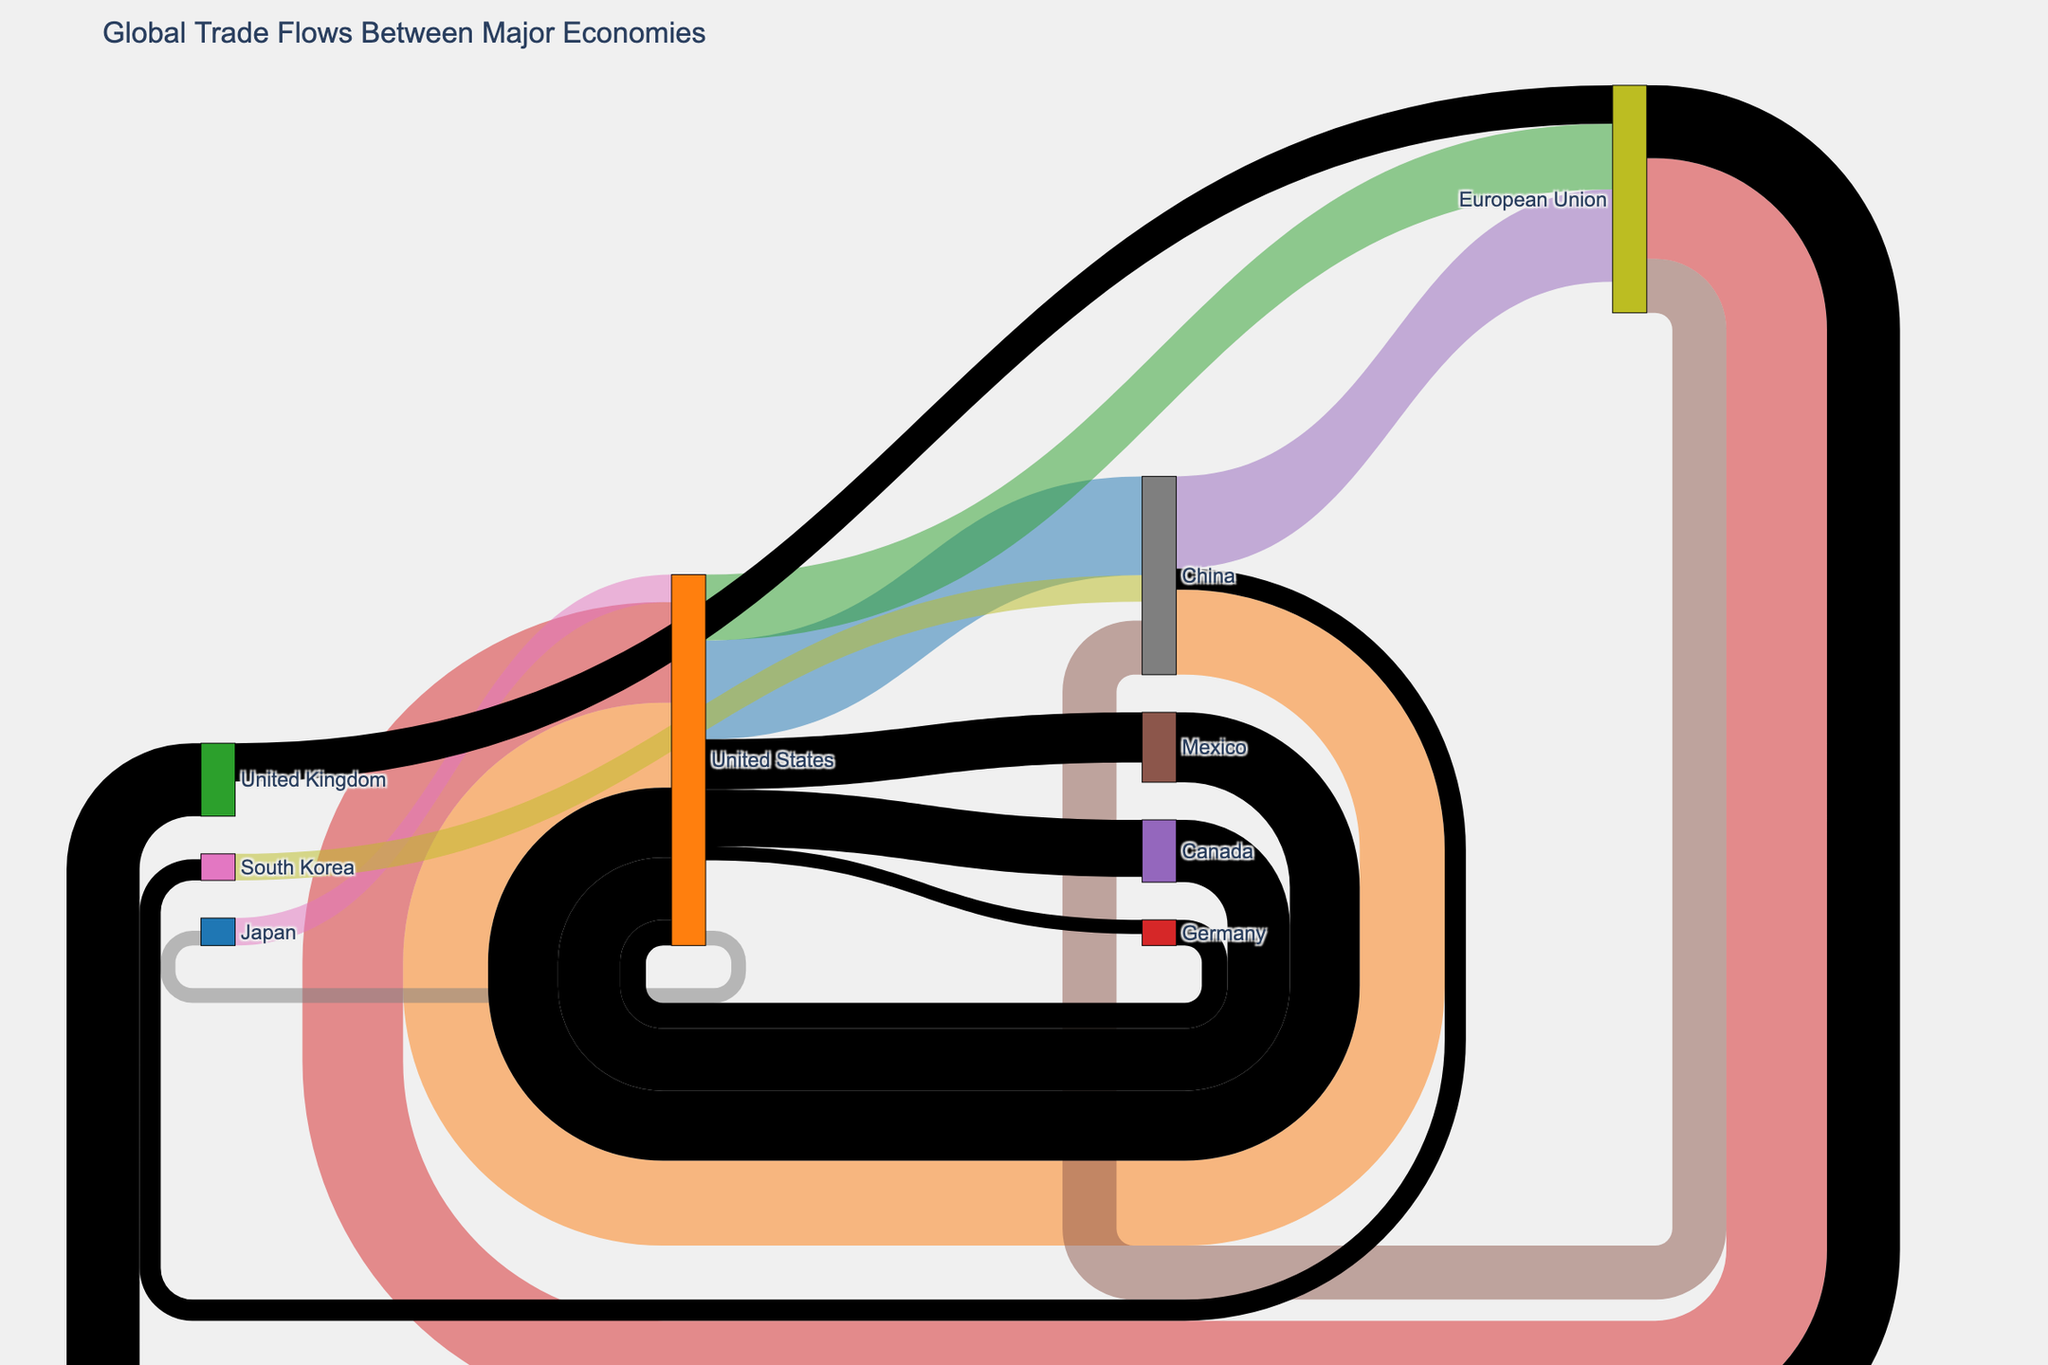What's the total value of exports from the United States to China and the European Union? Summing the export values from the United States to China (506.4) and the European Union (337.2) gives 506.4 + 337.2 = 843.6.
Answer: 843.6 Which country has the highest trade volume with the European Union? Comparing the trade flows between China, the United States, and the United Kingdom with the European Union, the United States has the highest value (515.6).
Answer: United States Does the United States import more from Germany or Japan? The import value from Germany is 131.6, while from Japan it is 140.7. Since 140.7 > 131.6, the United States imports more from Japan.
Answer: Japan What is the total volume of trade between the United States and Canada? Summing the values for both directions (319.4 from Canada to the United States and 292.3 from the United States to Canada) gives 319.4 + 292.3 = 611.7.
Answer: 611.7 What is the net trade balance between China and the European Union? The value from China to the European Union is 472.7, and from the European Union to China is 276.6. The net trade balance is 472.7 - 276.6 = 196.1.
Answer: 196.1 Which two countries appear to have the most balanced trade flows? Looking at the values, the trade flows between the United States and Canada (319.4 imports vs. 292.3 exports) are closer compared to other pairs.
Answer: United States and Canada Compare the import volumes of European Union from China and the United States. Which is higher? Comparing the values, the European Union imports 472.7 from China and 515.6 from the United States. Since 515.6 > 472.7, imports from the United States are higher.
Answer: United States Looking at South Korea and China, who trades more with whom? South Korea exports 136.2 to China, and China exports 108.4 to South Korea. Since 136.2 > 108.4, South Korea trades more with China.
Answer: South Korea trades more with China What is the total value of trade flowing in and out of the United States? Summing all the values of imports and exports involving the United States: 506.4 + 435.5 + 337.2 + 515.6 + 140.7 + 75.2 + 131.6 + 72.7 + 319.4 + 292.3 + 358.1 + 256.4 = 3440.1.
Answer: 3440.1 